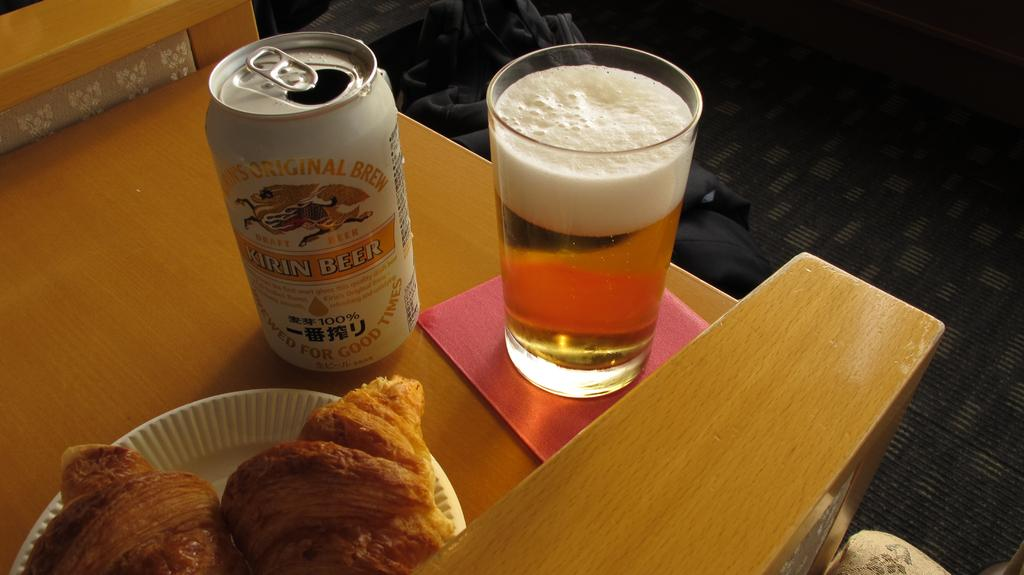What piece of furniture is present in the image? There is a table in the image. What items are placed on the table? There are plates, a coke tin, a glass containing a drink, and puffs on the plate. What type of drink is in the glass? The type of drink in the glass is not specified in the image. What is the shape of the container holding the drink? The container holding the drink is a glass. Reasoning: Let' Let's think step by step in order to produce the conversation. We start by identifying the main subject in the image, which is the table. Then, we expand the conversation to include other items that are also visible on the table, such as plates, a coke tin, a glass containing a drink, and puffs. Each question is designed to elicit a specific detail about the image that is known from the provided facts. Absurd Question/Answer: Can you see any shoes running in the image? There are no shoes or running depicted in the image. Is there a robin perched on the table in the image? No, there is no robin present in the image. Can you see any shoes running in the image? There are no shoes or running depicted in the image. Is there a robin perched on the table in the image? No, there is no robin present in the image. 